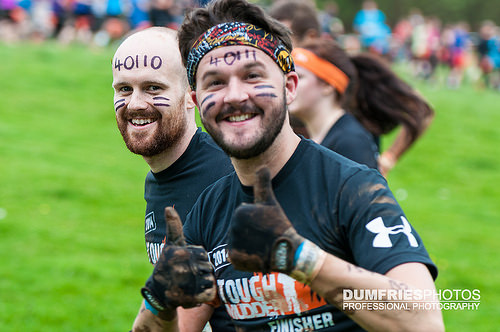<image>
Is the gloves on the man? No. The gloves is not positioned on the man. They may be near each other, but the gloves is not supported by or resting on top of the man. 